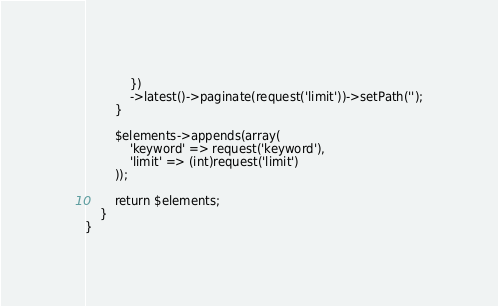<code> <loc_0><loc_0><loc_500><loc_500><_PHP_>            })
            ->latest()->paginate(request('limit'))->setPath('');
        }
            
        $elements->appends(array(
            'keyword' => request('keyword'),
            'limit' => (int)request('limit')
        ));

        return $elements;
    }
}
</code> 